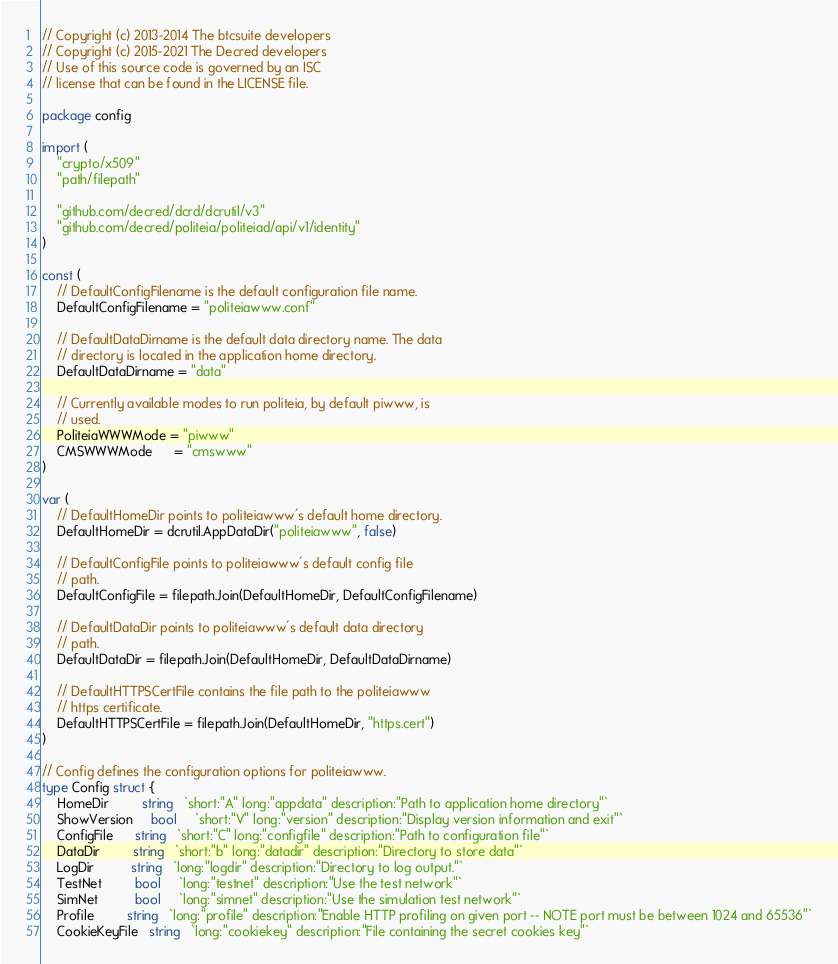Convert code to text. <code><loc_0><loc_0><loc_500><loc_500><_Go_>// Copyright (c) 2013-2014 The btcsuite developers
// Copyright (c) 2015-2021 The Decred developers
// Use of this source code is governed by an ISC
// license that can be found in the LICENSE file.

package config

import (
	"crypto/x509"
	"path/filepath"

	"github.com/decred/dcrd/dcrutil/v3"
	"github.com/decred/politeia/politeiad/api/v1/identity"
)

const (
	// DefaultConfigFilename is the default configuration file name.
	DefaultConfigFilename = "politeiawww.conf"

	// DefaultDataDirname is the default data directory name. The data
	// directory is located in the application home directory.
	DefaultDataDirname = "data"

	// Currently available modes to run politeia, by default piwww, is
	// used.
	PoliteiaWWWMode = "piwww"
	CMSWWWMode      = "cmswww"
)

var (
	// DefaultHomeDir points to politeiawww's default home directory.
	DefaultHomeDir = dcrutil.AppDataDir("politeiawww", false)

	// DefaultConfigFile points to politeiawww's default config file
	// path.
	DefaultConfigFile = filepath.Join(DefaultHomeDir, DefaultConfigFilename)

	// DefaultDataDir points to politeiawww's default data directory
	// path.
	DefaultDataDir = filepath.Join(DefaultHomeDir, DefaultDataDirname)

	// DefaultHTTPSCertFile contains the file path to the politeiawww
	// https certificate.
	DefaultHTTPSCertFile = filepath.Join(DefaultHomeDir, "https.cert")
)

// Config defines the configuration options for politeiawww.
type Config struct {
	HomeDir         string   `short:"A" long:"appdata" description:"Path to application home directory"`
	ShowVersion     bool     `short:"V" long:"version" description:"Display version information and exit"`
	ConfigFile      string   `short:"C" long:"configfile" description:"Path to configuration file"`
	DataDir         string   `short:"b" long:"datadir" description:"Directory to store data"`
	LogDir          string   `long:"logdir" description:"Directory to log output."`
	TestNet         bool     `long:"testnet" description:"Use the test network"`
	SimNet          bool     `long:"simnet" description:"Use the simulation test network"`
	Profile         string   `long:"profile" description:"Enable HTTP profiling on given port -- NOTE port must be between 1024 and 65536"`
	CookieKeyFile   string   `long:"cookiekey" description:"File containing the secret cookies key"`</code> 